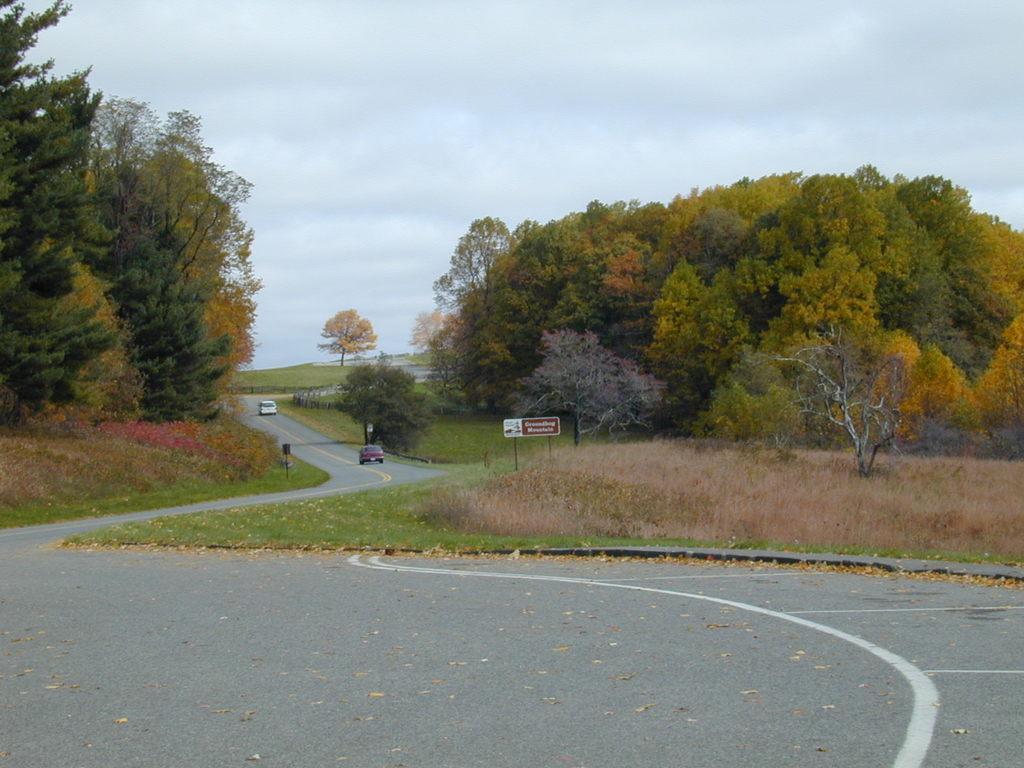In one or two sentences, can you explain what this image depicts? In this picture we can see dried leaves and cars on the road, grass, trees, name board, some objects and in the background we can see the sky with clouds. 